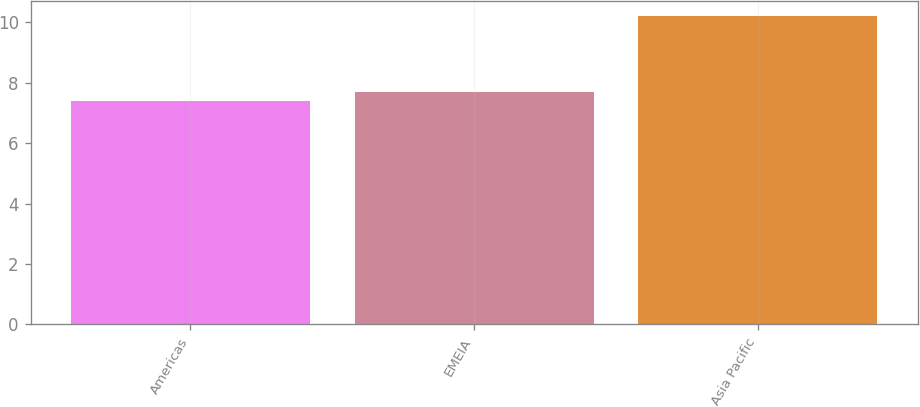Convert chart. <chart><loc_0><loc_0><loc_500><loc_500><bar_chart><fcel>Americas<fcel>EMEIA<fcel>Asia Pacific<nl><fcel>7.4<fcel>7.7<fcel>10.2<nl></chart> 